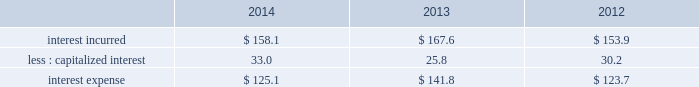Interest expense .
2014 vs .
2013 interest incurred decreased $ 9.5 .
The decrease was primarily due to a lower average interest rate on the debt portfolio which reduced interest by $ 13 , partially offset by a higher average debt balance which increased interest by $ 6 .
The change in capitalized interest was driven by a higher carrying value in construction in progress .
2013 vs .
2012 interest incurred increased $ 13.7 .
The increase was driven primarily by a higher average debt balance for $ 41 , partially offset by a lower average interest rate on the debt portfolio of $ 24 .
The change in capitalized interest was driven by a decrease in project spending and a lower average interest rate .
Effective tax rate the effective tax rate equals the income tax provision divided by income from continuing operations before taxes .
Refer to note 22 , income taxes , to the consolidated financial statements for details on factors affecting the effective tax rate .
2014 vs .
2013 on a gaap basis , the effective tax rate was 27.0% ( 27.0 % ) and 22.8% ( 22.8 % ) in 2014 and 2013 , respectively .
The effective tax rate was higher in the current year primarily due to the goodwill impairment charge of $ 305.2 , which was not deductible for tax purposes , and the chilean tax reform enacted in september 2014 which increased income tax expense by $ 20.6 .
These impacts were partially offset by an income tax benefit of $ 51.6 associated with losses from transactions and a tax election in a non-u.s .
Subsidiary .
The prior year rate included income tax benefits of $ 73.7 related to the business restructuring and cost reduction plans and $ 3.7 for the advisory costs .
Refer to note 4 , business restructuring and cost reduction actions ; note 9 , goodwill ; note 22 , income taxes ; and note 23 , supplemental information , to the consolidated financial statements for details on these transactions .
On a non-gaap basis , the effective tax rate was 24.0% ( 24.0 % ) and 24.2% ( 24.2 % ) in 2014 and 2013 , respectively .
2013 vs .
2012 on a gaap basis , the effective tax rate was 22.8% ( 22.8 % ) and 21.9% ( 21.9 % ) in 2013 and 2012 , respectively .
The effective rate in 2013 includes income tax benefits of $ 73.7 related to the business restructuring and cost reduction plans and $ 3.7 for the advisory costs .
The effective rate in 2012 includes income tax benefits of $ 105.0 related to the business restructuring and cost reduction plans , $ 58.3 related to the second quarter spanish tax ruling , and $ 3.7 related to the customer bankruptcy charge , offset by income tax expense of $ 43.8 related to the first quarter spanish tax settlement and $ 31.3 related to the gain on the previously held equity interest in da nanomaterials .
Refer to note 4 , business restructuring and cost reduction actions ; note 5 , business combinations ; note 22 , income taxes ; and note 23 , supplemental information , to the consolidated financial statements for details on these transactions .
On a non-gaap basis , the effective tax rate was 24.2% ( 24.2 % ) in both 2013 and 2012 .
Discontinued operations during the second quarter of 2012 , the board of directors authorized the sale of our homecare business , which had previously been reported as part of the merchant gases operating segment .
In 2012 , we sold the majority of our homecare business to the linde group for sale proceeds of 20ac590 million ( $ 777 ) and recognized a gain of $ 207.4 ( $ 150.3 after-tax , or $ .70 per share ) .
In addition , an impairment charge of $ 33.5 ( $ 29.5 after-tax , or $ .14 per share ) was recorded to write down the remaining business , which was primarily in the united kingdom and ireland , to its estimated net realizable value .
In 2013 , we recorded an additional charge of $ 18.7 ( $ 13.6 after-tax , or $ .06 per share ) to update our estimate of the net realizable value .
In 2014 , a gain of $ 3.9 was recognized for the sale of the remaining homecare business and settlement of contingencies on the sale to the linde group .
Refer to note 3 , discontinued operations , to the consolidated financial statements for additional details on this business. .
What is the increase observed in the interest expense during 2012 and 2013? 
Rationale: it is the total expenses in 2013 divided by the 2012's then turned into a percentage .
Computations: ((141.8 / 123.7) - 1)
Answer: 0.14632. 